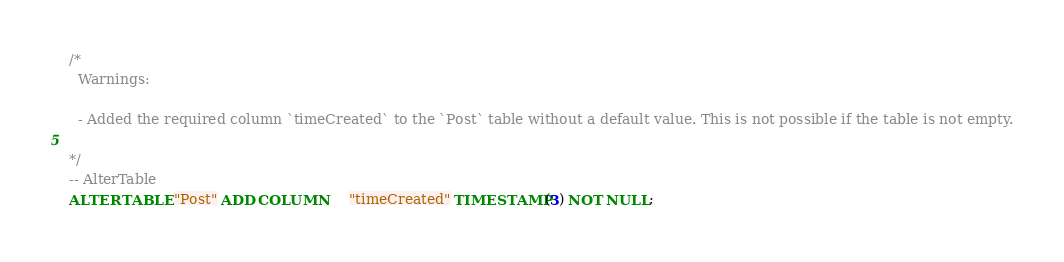Convert code to text. <code><loc_0><loc_0><loc_500><loc_500><_SQL_>/*
  Warnings:

  - Added the required column `timeCreated` to the `Post` table without a default value. This is not possible if the table is not empty.

*/
-- AlterTable
ALTER TABLE "Post" ADD COLUMN     "timeCreated" TIMESTAMP(3) NOT NULL;
</code> 